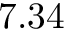<formula> <loc_0><loc_0><loc_500><loc_500>7 . 3 4</formula> 